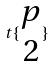Convert formula to latex. <formula><loc_0><loc_0><loc_500><loc_500>t \{ \begin{matrix} p \\ 2 \end{matrix} \}</formula> 